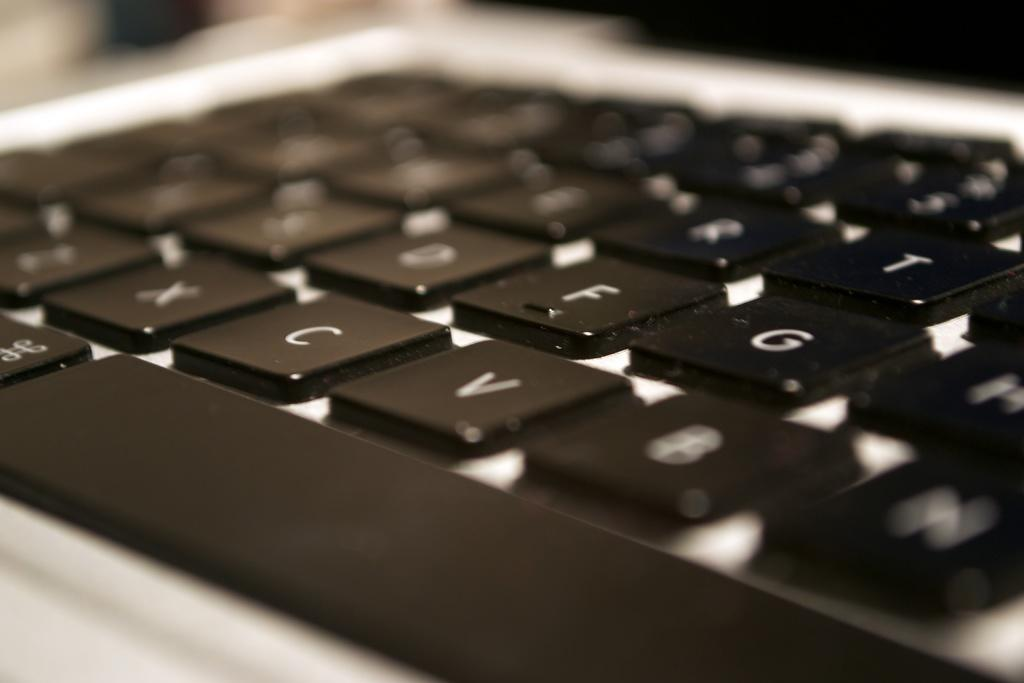<image>
Present a compact description of the photo's key features. A close up of a computer keyboard with visible X, C, and V keys. 